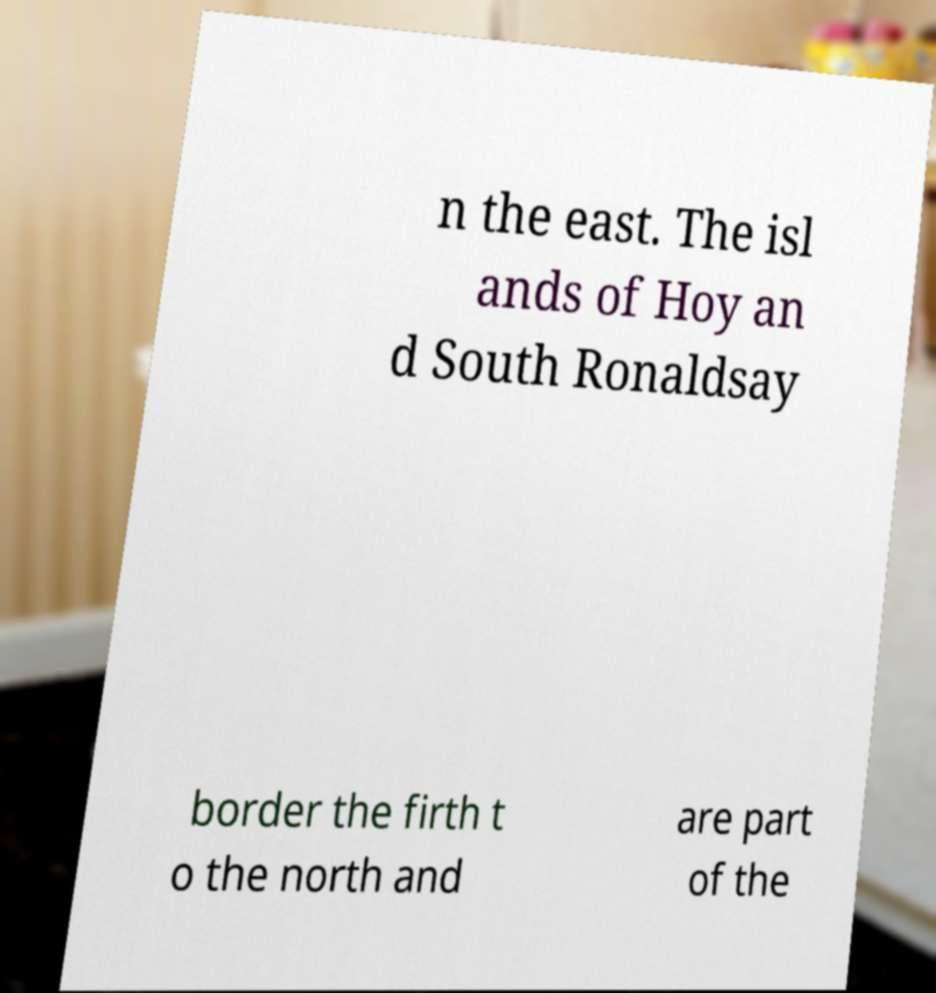For documentation purposes, I need the text within this image transcribed. Could you provide that? n the east. The isl ands of Hoy an d South Ronaldsay border the firth t o the north and are part of the 